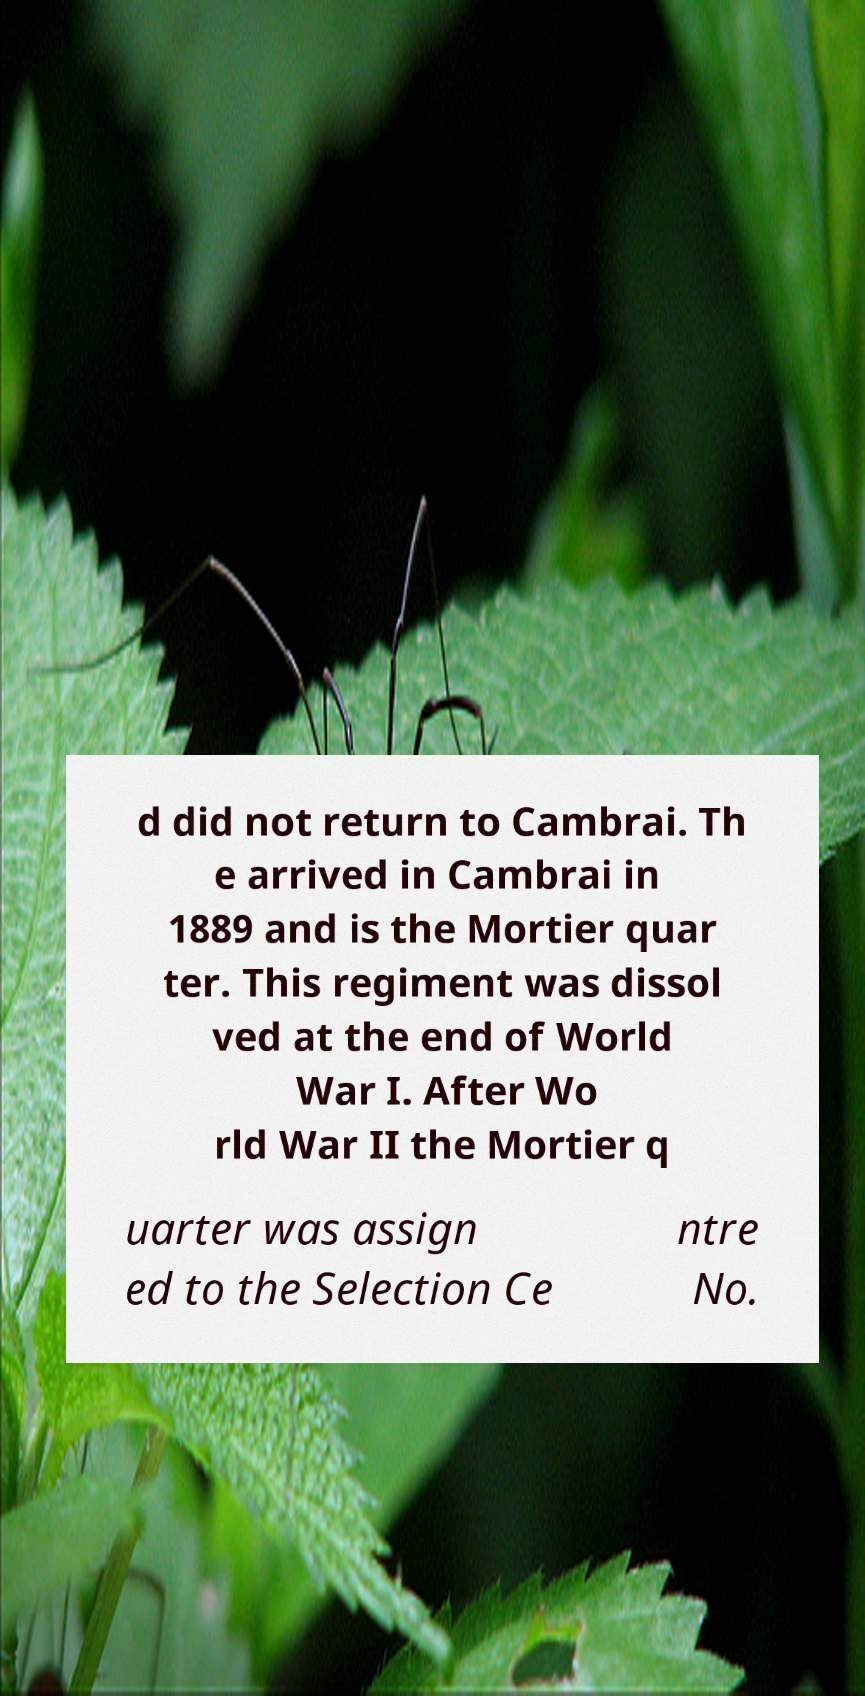I need the written content from this picture converted into text. Can you do that? d did not return to Cambrai. Th e arrived in Cambrai in 1889 and is the Mortier quar ter. This regiment was dissol ved at the end of World War I. After Wo rld War II the Mortier q uarter was assign ed to the Selection Ce ntre No. 